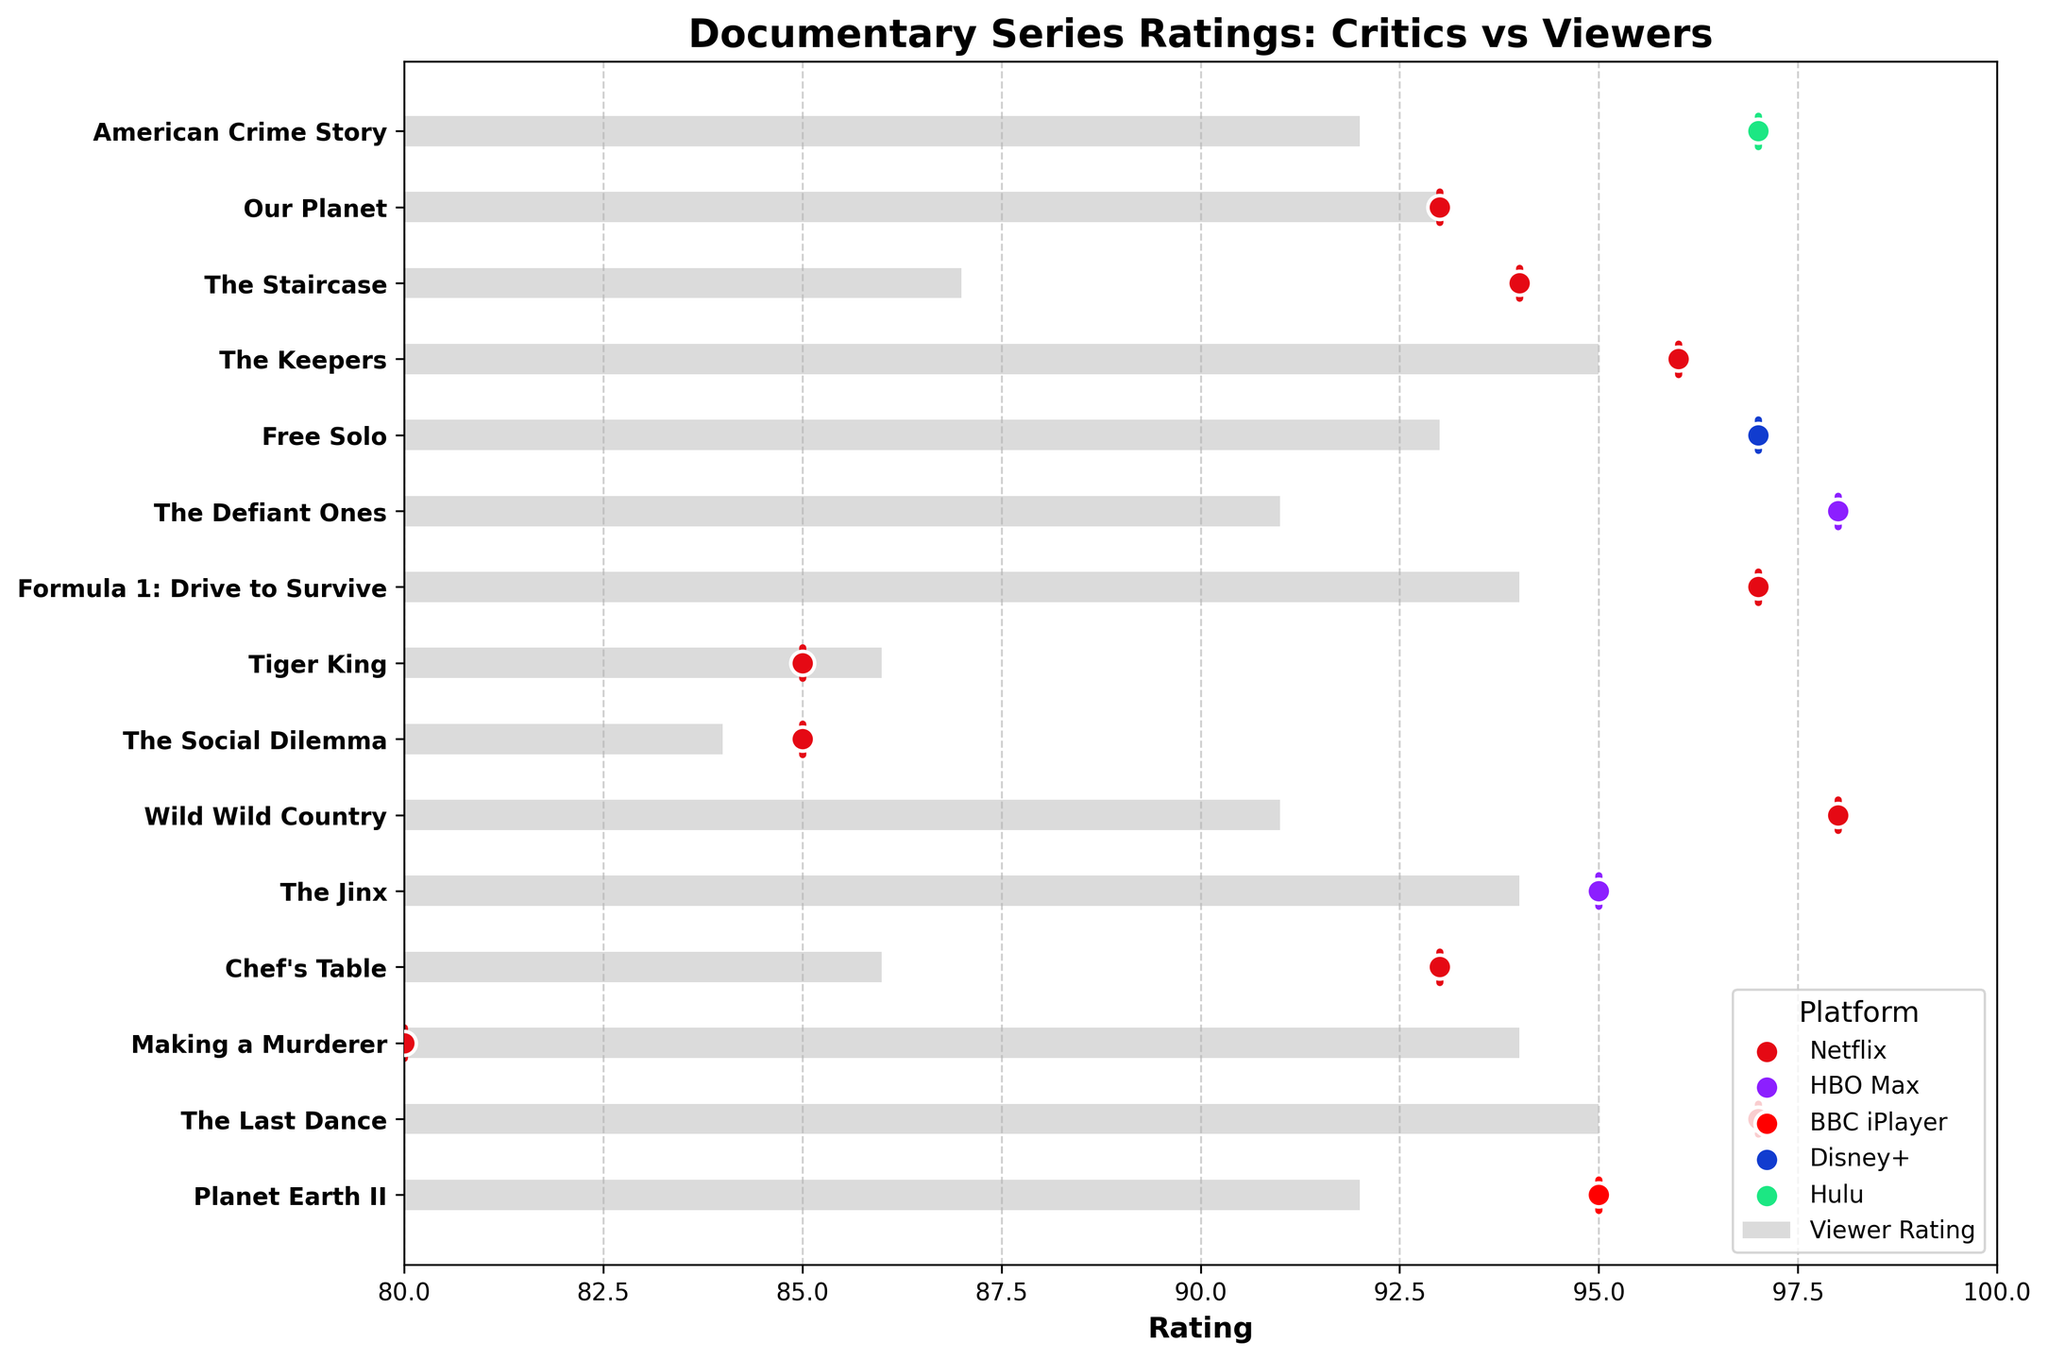What is the title of the figure? The title is usually displayed at the top of the figure. In this case, the title is clearly mentioned at the top.
Answer: Documentary Series Ratings: Critics vs Viewers How many documentary series are listed in the chart? Count the number of bars (titles) on the y-axis. By counting, we find there are 15 titles listed.
Answer: 15 Which documentary series has the highest critical rating? Identify the series with the highest vertical line on the chart. "The Defiant Ones" and "Wild Wild Country" have the highest critical rating of 98.
Answer: The Defiant Ones and Wild Wild Country Which platform has the most documentary series listed? Count the number of occurrences of each platform from the color-coded lines. Netflix appears the most with 10 series.
Answer: Netflix What is the difference between the critical rating and viewer rating for "Making a Murderer"? The critical rating for "Making a Murderer" is 80, and the viewer rating is 94. The difference is 94 - 80 = 14.
Answer: 14 Which series has the smallest difference between critical and viewer ratings? Compare the critical and viewer ratings for each series and find the smallest difference. "The Social Dilemma" has a difference of 1 (85 - 84 = 1).
Answer: The Social Dilemma Are there any series where the viewer rating is higher than the critical rating? Check each series to see if the viewer rating bar extends further to the right than the critical rating line. "Making a Murderer" is an example where the viewer rating (94) is higher than the critical rating (80).
Answer: Yes What is the average critical rating for all the series on Netflix? Find all critical ratings for Netflix series and calculate the average: (97 + 80 + 93 + 98 + 85 + 85 + 97 + 96 + 94 + 93) / 10 = 91.8.
Answer: 91.8 Which series on HBO Max has a higher viewer rating, "The Jinx" or "The Defiant Ones"? Compare the viewer ratings for "The Jinx" (94) and "The Defiant Ones" (91). "The Jinx" has a higher viewer rating.
Answer: The Jinx How does the critical rating for "Free Solo" compare to its viewer rating? Locate "Free Solo" and compare the critical rating (97) to the viewer rating (93). The critical rating is higher.
Answer: Critical rating is higher 